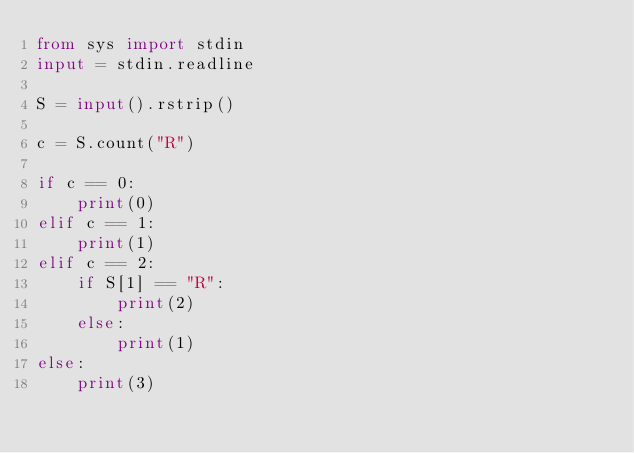Convert code to text. <code><loc_0><loc_0><loc_500><loc_500><_Python_>from sys import stdin
input = stdin.readline

S = input().rstrip()

c = S.count("R")

if c == 0:
    print(0)
elif c == 1:
    print(1)
elif c == 2:
    if S[1] == "R":
        print(2)
    else:
        print(1)
else:
    print(3)
</code> 